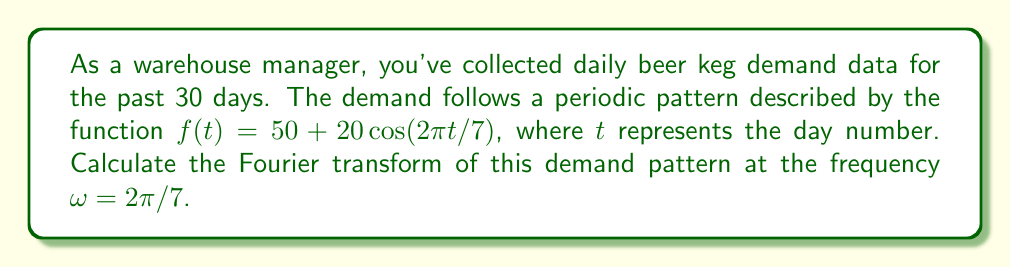Solve this math problem. To solve this problem, we'll follow these steps:

1) The general form of the Fourier transform for a continuous function $f(t)$ is:

   $$F(\omega) = \int_{-\infty}^{\infty} f(t)e^{-i\omega t}dt$$

2) Our function is $f(t) = 50 + 20\cos(2\pi t/7)$, and we need to calculate $F(2\pi/7)$.

3) Let's break this into two parts:
   
   $$F(2\pi/7) = \int_{-\infty}^{\infty} 50e^{-i(2\pi/7)t}dt + \int_{-\infty}^{\infty} 20\cos(2\pi t/7)e^{-i(2\pi/7)t}dt$$

4) For the first integral:
   
   $$\int_{-\infty}^{\infty} 50e^{-i(2\pi/7)t}dt = 50 \cdot 2\pi\delta(\omega) = 100\pi\delta(\omega)$$

   where $\delta(\omega)$ is the Dirac delta function.

5) For the second integral, we can use Euler's formula: $\cos(x) = \frac{1}{2}(e^{ix} + e^{-ix})$

   $$\int_{-\infty}^{\infty} 20\cos(2\pi t/7)e^{-i(2\pi/7)t}dt = 10\int_{-\infty}^{\infty} (e^{i(2\pi/7)t} + e^{-i(2\pi/7)t})e^{-i(2\pi/7)t}dt$$

6) Simplifying:

   $$= 10\int_{-\infty}^{\infty} (1 + e^{-i(4\pi/7)t})dt = 10 \cdot 2\pi\delta(0) + 10 \cdot 2\pi\delta(-2\pi/7)$$

7) The Dirac delta function $\delta(-2\pi/7)$ is zero for our frequency of interest $(2\pi/7)$, so we're left with:

   $$F(2\pi/7) = 100\pi\delta(2\pi/7) + 20\pi\delta(0)$$
Answer: $100\pi\delta(2\pi/7) + 20\pi\delta(0)$ 